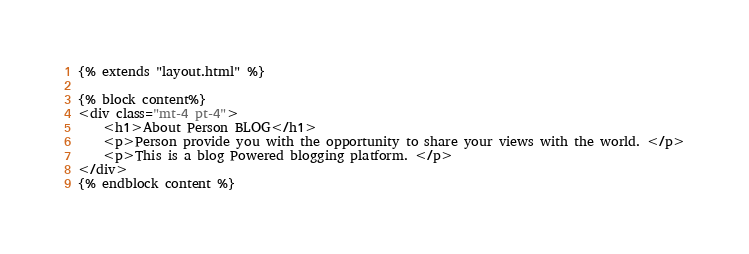Convert code to text. <code><loc_0><loc_0><loc_500><loc_500><_HTML_>
{% extends "layout.html" %}

{% block content%} 
<div class="mt-4 pt-4">
    <h1>About Person BLOG</h1>
    <p>Person provide you with the opportunity to share your views with the world. </p>
    <p>This is a blog Powered blogging platform. </p>
</div>
{% endblock content %}</code> 